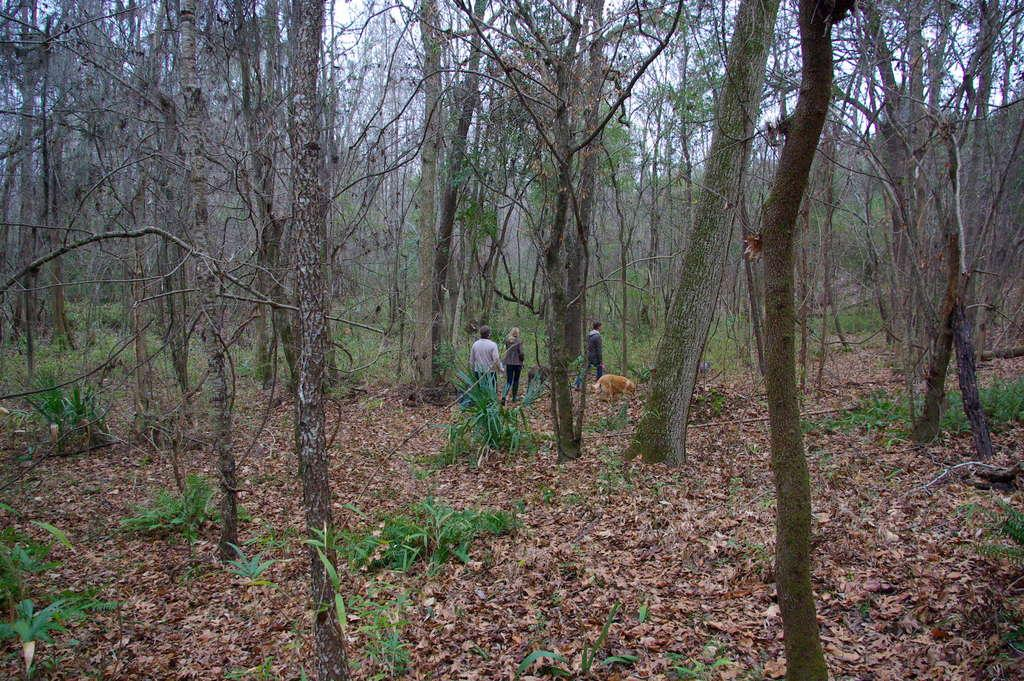What are the people in the image doing? The people in the image are walking on the ground. What is the condition of the ground in the image? The ground has mud. What can be seen in the background of the image? There are trees visible in the background of the image. What type of sack is being carried by the porter in the image? There is no porter or sack present in the image. What type of field can be seen in the image? There is no field visible in the image; it features people walking on a muddy ground with trees in the background. 